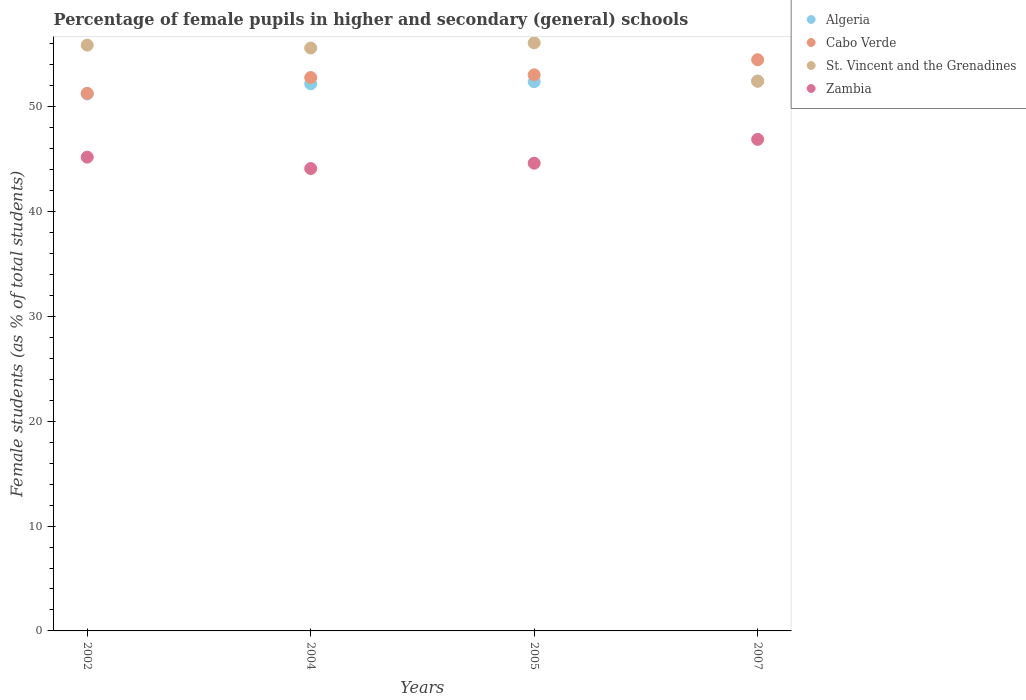How many different coloured dotlines are there?
Keep it short and to the point. 4. What is the percentage of female pupils in higher and secondary schools in Zambia in 2005?
Your answer should be compact. 44.62. Across all years, what is the maximum percentage of female pupils in higher and secondary schools in Cabo Verde?
Keep it short and to the point. 54.48. Across all years, what is the minimum percentage of female pupils in higher and secondary schools in St. Vincent and the Grenadines?
Ensure brevity in your answer.  52.44. What is the total percentage of female pupils in higher and secondary schools in Cabo Verde in the graph?
Provide a succinct answer. 211.59. What is the difference between the percentage of female pupils in higher and secondary schools in Cabo Verde in 2002 and that in 2007?
Offer a very short reply. -3.21. What is the difference between the percentage of female pupils in higher and secondary schools in St. Vincent and the Grenadines in 2004 and the percentage of female pupils in higher and secondary schools in Cabo Verde in 2005?
Offer a terse response. 2.56. What is the average percentage of female pupils in higher and secondary schools in Zambia per year?
Offer a very short reply. 45.2. In the year 2005, what is the difference between the percentage of female pupils in higher and secondary schools in Zambia and percentage of female pupils in higher and secondary schools in Algeria?
Provide a succinct answer. -7.78. What is the ratio of the percentage of female pupils in higher and secondary schools in Algeria in 2002 to that in 2004?
Offer a very short reply. 0.98. Is the percentage of female pupils in higher and secondary schools in Algeria in 2004 less than that in 2007?
Offer a very short reply. Yes. What is the difference between the highest and the second highest percentage of female pupils in higher and secondary schools in St. Vincent and the Grenadines?
Your answer should be very brief. 0.22. What is the difference between the highest and the lowest percentage of female pupils in higher and secondary schools in Algeria?
Your answer should be compact. 1.22. Is the sum of the percentage of female pupils in higher and secondary schools in Algeria in 2002 and 2007 greater than the maximum percentage of female pupils in higher and secondary schools in St. Vincent and the Grenadines across all years?
Provide a short and direct response. Yes. Is the percentage of female pupils in higher and secondary schools in Cabo Verde strictly greater than the percentage of female pupils in higher and secondary schools in Zambia over the years?
Your response must be concise. Yes. How many dotlines are there?
Ensure brevity in your answer.  4. How are the legend labels stacked?
Your response must be concise. Vertical. What is the title of the graph?
Your answer should be very brief. Percentage of female pupils in higher and secondary (general) schools. What is the label or title of the X-axis?
Your answer should be compact. Years. What is the label or title of the Y-axis?
Your answer should be compact. Female students (as % of total students). What is the Female students (as % of total students) of Algeria in 2002?
Ensure brevity in your answer.  51.23. What is the Female students (as % of total students) of Cabo Verde in 2002?
Your answer should be very brief. 51.28. What is the Female students (as % of total students) in St. Vincent and the Grenadines in 2002?
Offer a very short reply. 55.88. What is the Female students (as % of total students) in Zambia in 2002?
Your answer should be very brief. 45.19. What is the Female students (as % of total students) in Algeria in 2004?
Provide a short and direct response. 52.19. What is the Female students (as % of total students) of Cabo Verde in 2004?
Make the answer very short. 52.79. What is the Female students (as % of total students) of St. Vincent and the Grenadines in 2004?
Ensure brevity in your answer.  55.6. What is the Female students (as % of total students) in Zambia in 2004?
Give a very brief answer. 44.1. What is the Female students (as % of total students) of Algeria in 2005?
Your answer should be compact. 52.39. What is the Female students (as % of total students) of Cabo Verde in 2005?
Offer a very short reply. 53.04. What is the Female students (as % of total students) in St. Vincent and the Grenadines in 2005?
Ensure brevity in your answer.  56.09. What is the Female students (as % of total students) of Zambia in 2005?
Your answer should be compact. 44.62. What is the Female students (as % of total students) of Algeria in 2007?
Your answer should be compact. 52.45. What is the Female students (as % of total students) of Cabo Verde in 2007?
Provide a short and direct response. 54.48. What is the Female students (as % of total students) of St. Vincent and the Grenadines in 2007?
Make the answer very short. 52.44. What is the Female students (as % of total students) in Zambia in 2007?
Your answer should be compact. 46.89. Across all years, what is the maximum Female students (as % of total students) of Algeria?
Ensure brevity in your answer.  52.45. Across all years, what is the maximum Female students (as % of total students) of Cabo Verde?
Your answer should be very brief. 54.48. Across all years, what is the maximum Female students (as % of total students) in St. Vincent and the Grenadines?
Offer a very short reply. 56.09. Across all years, what is the maximum Female students (as % of total students) of Zambia?
Keep it short and to the point. 46.89. Across all years, what is the minimum Female students (as % of total students) of Algeria?
Your answer should be very brief. 51.23. Across all years, what is the minimum Female students (as % of total students) of Cabo Verde?
Your answer should be compact. 51.28. Across all years, what is the minimum Female students (as % of total students) in St. Vincent and the Grenadines?
Keep it short and to the point. 52.44. Across all years, what is the minimum Female students (as % of total students) of Zambia?
Your answer should be compact. 44.1. What is the total Female students (as % of total students) in Algeria in the graph?
Your answer should be very brief. 208.26. What is the total Female students (as % of total students) of Cabo Verde in the graph?
Provide a succinct answer. 211.59. What is the total Female students (as % of total students) in St. Vincent and the Grenadines in the graph?
Give a very brief answer. 220.01. What is the total Female students (as % of total students) in Zambia in the graph?
Give a very brief answer. 180.81. What is the difference between the Female students (as % of total students) in Algeria in 2002 and that in 2004?
Your answer should be compact. -0.96. What is the difference between the Female students (as % of total students) in Cabo Verde in 2002 and that in 2004?
Your answer should be very brief. -1.51. What is the difference between the Female students (as % of total students) of St. Vincent and the Grenadines in 2002 and that in 2004?
Your answer should be very brief. 0.28. What is the difference between the Female students (as % of total students) of Zambia in 2002 and that in 2004?
Your answer should be compact. 1.09. What is the difference between the Female students (as % of total students) of Algeria in 2002 and that in 2005?
Provide a succinct answer. -1.16. What is the difference between the Female students (as % of total students) of Cabo Verde in 2002 and that in 2005?
Give a very brief answer. -1.77. What is the difference between the Female students (as % of total students) in St. Vincent and the Grenadines in 2002 and that in 2005?
Provide a succinct answer. -0.22. What is the difference between the Female students (as % of total students) in Zambia in 2002 and that in 2005?
Your answer should be compact. 0.58. What is the difference between the Female students (as % of total students) in Algeria in 2002 and that in 2007?
Keep it short and to the point. -1.22. What is the difference between the Female students (as % of total students) in Cabo Verde in 2002 and that in 2007?
Keep it short and to the point. -3.21. What is the difference between the Female students (as % of total students) of St. Vincent and the Grenadines in 2002 and that in 2007?
Offer a very short reply. 3.44. What is the difference between the Female students (as % of total students) of Zambia in 2002 and that in 2007?
Your answer should be very brief. -1.69. What is the difference between the Female students (as % of total students) in Algeria in 2004 and that in 2005?
Provide a succinct answer. -0.2. What is the difference between the Female students (as % of total students) of Cabo Verde in 2004 and that in 2005?
Your response must be concise. -0.26. What is the difference between the Female students (as % of total students) in St. Vincent and the Grenadines in 2004 and that in 2005?
Provide a short and direct response. -0.49. What is the difference between the Female students (as % of total students) in Zambia in 2004 and that in 2005?
Provide a short and direct response. -0.51. What is the difference between the Female students (as % of total students) in Algeria in 2004 and that in 2007?
Offer a very short reply. -0.26. What is the difference between the Female students (as % of total students) in Cabo Verde in 2004 and that in 2007?
Provide a short and direct response. -1.7. What is the difference between the Female students (as % of total students) in St. Vincent and the Grenadines in 2004 and that in 2007?
Offer a terse response. 3.17. What is the difference between the Female students (as % of total students) of Zambia in 2004 and that in 2007?
Give a very brief answer. -2.79. What is the difference between the Female students (as % of total students) in Algeria in 2005 and that in 2007?
Provide a short and direct response. -0.06. What is the difference between the Female students (as % of total students) in Cabo Verde in 2005 and that in 2007?
Offer a very short reply. -1.44. What is the difference between the Female students (as % of total students) of St. Vincent and the Grenadines in 2005 and that in 2007?
Your answer should be very brief. 3.66. What is the difference between the Female students (as % of total students) of Zambia in 2005 and that in 2007?
Provide a succinct answer. -2.27. What is the difference between the Female students (as % of total students) of Algeria in 2002 and the Female students (as % of total students) of Cabo Verde in 2004?
Offer a very short reply. -1.56. What is the difference between the Female students (as % of total students) of Algeria in 2002 and the Female students (as % of total students) of St. Vincent and the Grenadines in 2004?
Your response must be concise. -4.37. What is the difference between the Female students (as % of total students) in Algeria in 2002 and the Female students (as % of total students) in Zambia in 2004?
Your answer should be very brief. 7.12. What is the difference between the Female students (as % of total students) in Cabo Verde in 2002 and the Female students (as % of total students) in St. Vincent and the Grenadines in 2004?
Provide a short and direct response. -4.33. What is the difference between the Female students (as % of total students) of Cabo Verde in 2002 and the Female students (as % of total students) of Zambia in 2004?
Ensure brevity in your answer.  7.17. What is the difference between the Female students (as % of total students) of St. Vincent and the Grenadines in 2002 and the Female students (as % of total students) of Zambia in 2004?
Make the answer very short. 11.77. What is the difference between the Female students (as % of total students) of Algeria in 2002 and the Female students (as % of total students) of Cabo Verde in 2005?
Keep it short and to the point. -1.82. What is the difference between the Female students (as % of total students) in Algeria in 2002 and the Female students (as % of total students) in St. Vincent and the Grenadines in 2005?
Make the answer very short. -4.87. What is the difference between the Female students (as % of total students) in Algeria in 2002 and the Female students (as % of total students) in Zambia in 2005?
Ensure brevity in your answer.  6.61. What is the difference between the Female students (as % of total students) of Cabo Verde in 2002 and the Female students (as % of total students) of St. Vincent and the Grenadines in 2005?
Make the answer very short. -4.82. What is the difference between the Female students (as % of total students) of Cabo Verde in 2002 and the Female students (as % of total students) of Zambia in 2005?
Offer a very short reply. 6.66. What is the difference between the Female students (as % of total students) of St. Vincent and the Grenadines in 2002 and the Female students (as % of total students) of Zambia in 2005?
Keep it short and to the point. 11.26. What is the difference between the Female students (as % of total students) of Algeria in 2002 and the Female students (as % of total students) of Cabo Verde in 2007?
Make the answer very short. -3.26. What is the difference between the Female students (as % of total students) in Algeria in 2002 and the Female students (as % of total students) in St. Vincent and the Grenadines in 2007?
Provide a succinct answer. -1.21. What is the difference between the Female students (as % of total students) of Algeria in 2002 and the Female students (as % of total students) of Zambia in 2007?
Make the answer very short. 4.34. What is the difference between the Female students (as % of total students) of Cabo Verde in 2002 and the Female students (as % of total students) of St. Vincent and the Grenadines in 2007?
Offer a very short reply. -1.16. What is the difference between the Female students (as % of total students) of Cabo Verde in 2002 and the Female students (as % of total students) of Zambia in 2007?
Give a very brief answer. 4.39. What is the difference between the Female students (as % of total students) of St. Vincent and the Grenadines in 2002 and the Female students (as % of total students) of Zambia in 2007?
Offer a terse response. 8.99. What is the difference between the Female students (as % of total students) in Algeria in 2004 and the Female students (as % of total students) in Cabo Verde in 2005?
Offer a terse response. -0.85. What is the difference between the Female students (as % of total students) of Algeria in 2004 and the Female students (as % of total students) of St. Vincent and the Grenadines in 2005?
Provide a succinct answer. -3.9. What is the difference between the Female students (as % of total students) in Algeria in 2004 and the Female students (as % of total students) in Zambia in 2005?
Provide a succinct answer. 7.57. What is the difference between the Female students (as % of total students) in Cabo Verde in 2004 and the Female students (as % of total students) in St. Vincent and the Grenadines in 2005?
Offer a very short reply. -3.31. What is the difference between the Female students (as % of total students) of Cabo Verde in 2004 and the Female students (as % of total students) of Zambia in 2005?
Your response must be concise. 8.17. What is the difference between the Female students (as % of total students) in St. Vincent and the Grenadines in 2004 and the Female students (as % of total students) in Zambia in 2005?
Your response must be concise. 10.99. What is the difference between the Female students (as % of total students) of Algeria in 2004 and the Female students (as % of total students) of Cabo Verde in 2007?
Keep it short and to the point. -2.29. What is the difference between the Female students (as % of total students) of Algeria in 2004 and the Female students (as % of total students) of St. Vincent and the Grenadines in 2007?
Make the answer very short. -0.25. What is the difference between the Female students (as % of total students) of Algeria in 2004 and the Female students (as % of total students) of Zambia in 2007?
Offer a terse response. 5.3. What is the difference between the Female students (as % of total students) in Cabo Verde in 2004 and the Female students (as % of total students) in St. Vincent and the Grenadines in 2007?
Ensure brevity in your answer.  0.35. What is the difference between the Female students (as % of total students) in Cabo Verde in 2004 and the Female students (as % of total students) in Zambia in 2007?
Your answer should be compact. 5.9. What is the difference between the Female students (as % of total students) in St. Vincent and the Grenadines in 2004 and the Female students (as % of total students) in Zambia in 2007?
Provide a succinct answer. 8.71. What is the difference between the Female students (as % of total students) of Algeria in 2005 and the Female students (as % of total students) of Cabo Verde in 2007?
Provide a succinct answer. -2.09. What is the difference between the Female students (as % of total students) in Algeria in 2005 and the Female students (as % of total students) in St. Vincent and the Grenadines in 2007?
Provide a succinct answer. -0.05. What is the difference between the Female students (as % of total students) of Algeria in 2005 and the Female students (as % of total students) of Zambia in 2007?
Ensure brevity in your answer.  5.5. What is the difference between the Female students (as % of total students) of Cabo Verde in 2005 and the Female students (as % of total students) of St. Vincent and the Grenadines in 2007?
Provide a succinct answer. 0.61. What is the difference between the Female students (as % of total students) in Cabo Verde in 2005 and the Female students (as % of total students) in Zambia in 2007?
Your answer should be very brief. 6.15. What is the difference between the Female students (as % of total students) of St. Vincent and the Grenadines in 2005 and the Female students (as % of total students) of Zambia in 2007?
Provide a short and direct response. 9.21. What is the average Female students (as % of total students) of Algeria per year?
Provide a succinct answer. 52.07. What is the average Female students (as % of total students) of Cabo Verde per year?
Make the answer very short. 52.9. What is the average Female students (as % of total students) of St. Vincent and the Grenadines per year?
Give a very brief answer. 55. What is the average Female students (as % of total students) in Zambia per year?
Your answer should be very brief. 45.2. In the year 2002, what is the difference between the Female students (as % of total students) of Algeria and Female students (as % of total students) of Cabo Verde?
Keep it short and to the point. -0.05. In the year 2002, what is the difference between the Female students (as % of total students) in Algeria and Female students (as % of total students) in St. Vincent and the Grenadines?
Provide a short and direct response. -4.65. In the year 2002, what is the difference between the Female students (as % of total students) in Algeria and Female students (as % of total students) in Zambia?
Your answer should be very brief. 6.03. In the year 2002, what is the difference between the Female students (as % of total students) of Cabo Verde and Female students (as % of total students) of St. Vincent and the Grenadines?
Give a very brief answer. -4.6. In the year 2002, what is the difference between the Female students (as % of total students) in Cabo Verde and Female students (as % of total students) in Zambia?
Your response must be concise. 6.08. In the year 2002, what is the difference between the Female students (as % of total students) in St. Vincent and the Grenadines and Female students (as % of total students) in Zambia?
Your answer should be very brief. 10.68. In the year 2004, what is the difference between the Female students (as % of total students) in Algeria and Female students (as % of total students) in Cabo Verde?
Keep it short and to the point. -0.6. In the year 2004, what is the difference between the Female students (as % of total students) of Algeria and Female students (as % of total students) of St. Vincent and the Grenadines?
Provide a succinct answer. -3.41. In the year 2004, what is the difference between the Female students (as % of total students) of Algeria and Female students (as % of total students) of Zambia?
Provide a succinct answer. 8.09. In the year 2004, what is the difference between the Female students (as % of total students) in Cabo Verde and Female students (as % of total students) in St. Vincent and the Grenadines?
Offer a very short reply. -2.81. In the year 2004, what is the difference between the Female students (as % of total students) in Cabo Verde and Female students (as % of total students) in Zambia?
Provide a short and direct response. 8.68. In the year 2004, what is the difference between the Female students (as % of total students) in St. Vincent and the Grenadines and Female students (as % of total students) in Zambia?
Offer a very short reply. 11.5. In the year 2005, what is the difference between the Female students (as % of total students) of Algeria and Female students (as % of total students) of Cabo Verde?
Provide a short and direct response. -0.65. In the year 2005, what is the difference between the Female students (as % of total students) in Algeria and Female students (as % of total students) in St. Vincent and the Grenadines?
Provide a succinct answer. -3.7. In the year 2005, what is the difference between the Female students (as % of total students) in Algeria and Female students (as % of total students) in Zambia?
Ensure brevity in your answer.  7.78. In the year 2005, what is the difference between the Female students (as % of total students) in Cabo Verde and Female students (as % of total students) in St. Vincent and the Grenadines?
Your response must be concise. -3.05. In the year 2005, what is the difference between the Female students (as % of total students) in Cabo Verde and Female students (as % of total students) in Zambia?
Provide a short and direct response. 8.43. In the year 2005, what is the difference between the Female students (as % of total students) of St. Vincent and the Grenadines and Female students (as % of total students) of Zambia?
Your answer should be very brief. 11.48. In the year 2007, what is the difference between the Female students (as % of total students) in Algeria and Female students (as % of total students) in Cabo Verde?
Provide a short and direct response. -2.03. In the year 2007, what is the difference between the Female students (as % of total students) of Algeria and Female students (as % of total students) of St. Vincent and the Grenadines?
Provide a succinct answer. 0.01. In the year 2007, what is the difference between the Female students (as % of total students) in Algeria and Female students (as % of total students) in Zambia?
Keep it short and to the point. 5.56. In the year 2007, what is the difference between the Female students (as % of total students) of Cabo Verde and Female students (as % of total students) of St. Vincent and the Grenadines?
Your response must be concise. 2.05. In the year 2007, what is the difference between the Female students (as % of total students) of Cabo Verde and Female students (as % of total students) of Zambia?
Your response must be concise. 7.59. In the year 2007, what is the difference between the Female students (as % of total students) in St. Vincent and the Grenadines and Female students (as % of total students) in Zambia?
Make the answer very short. 5.55. What is the ratio of the Female students (as % of total students) in Algeria in 2002 to that in 2004?
Offer a very short reply. 0.98. What is the ratio of the Female students (as % of total students) of Cabo Verde in 2002 to that in 2004?
Give a very brief answer. 0.97. What is the ratio of the Female students (as % of total students) of Zambia in 2002 to that in 2004?
Provide a short and direct response. 1.02. What is the ratio of the Female students (as % of total students) in Algeria in 2002 to that in 2005?
Offer a terse response. 0.98. What is the ratio of the Female students (as % of total students) of Cabo Verde in 2002 to that in 2005?
Provide a succinct answer. 0.97. What is the ratio of the Female students (as % of total students) of St. Vincent and the Grenadines in 2002 to that in 2005?
Give a very brief answer. 1. What is the ratio of the Female students (as % of total students) of Zambia in 2002 to that in 2005?
Provide a short and direct response. 1.01. What is the ratio of the Female students (as % of total students) of Algeria in 2002 to that in 2007?
Give a very brief answer. 0.98. What is the ratio of the Female students (as % of total students) in Cabo Verde in 2002 to that in 2007?
Your response must be concise. 0.94. What is the ratio of the Female students (as % of total students) in St. Vincent and the Grenadines in 2002 to that in 2007?
Offer a very short reply. 1.07. What is the ratio of the Female students (as % of total students) in Zambia in 2002 to that in 2007?
Your answer should be compact. 0.96. What is the ratio of the Female students (as % of total students) in Cabo Verde in 2004 to that in 2005?
Your response must be concise. 1. What is the ratio of the Female students (as % of total students) of Algeria in 2004 to that in 2007?
Keep it short and to the point. 0.99. What is the ratio of the Female students (as % of total students) of Cabo Verde in 2004 to that in 2007?
Offer a terse response. 0.97. What is the ratio of the Female students (as % of total students) of St. Vincent and the Grenadines in 2004 to that in 2007?
Your response must be concise. 1.06. What is the ratio of the Female students (as % of total students) in Zambia in 2004 to that in 2007?
Your answer should be compact. 0.94. What is the ratio of the Female students (as % of total students) of Algeria in 2005 to that in 2007?
Provide a short and direct response. 1. What is the ratio of the Female students (as % of total students) in Cabo Verde in 2005 to that in 2007?
Offer a terse response. 0.97. What is the ratio of the Female students (as % of total students) in St. Vincent and the Grenadines in 2005 to that in 2007?
Your answer should be very brief. 1.07. What is the ratio of the Female students (as % of total students) in Zambia in 2005 to that in 2007?
Your answer should be compact. 0.95. What is the difference between the highest and the second highest Female students (as % of total students) in Algeria?
Ensure brevity in your answer.  0.06. What is the difference between the highest and the second highest Female students (as % of total students) in Cabo Verde?
Offer a terse response. 1.44. What is the difference between the highest and the second highest Female students (as % of total students) in St. Vincent and the Grenadines?
Provide a short and direct response. 0.22. What is the difference between the highest and the second highest Female students (as % of total students) in Zambia?
Offer a very short reply. 1.69. What is the difference between the highest and the lowest Female students (as % of total students) of Algeria?
Offer a terse response. 1.22. What is the difference between the highest and the lowest Female students (as % of total students) of Cabo Verde?
Provide a succinct answer. 3.21. What is the difference between the highest and the lowest Female students (as % of total students) in St. Vincent and the Grenadines?
Keep it short and to the point. 3.66. What is the difference between the highest and the lowest Female students (as % of total students) of Zambia?
Provide a succinct answer. 2.79. 